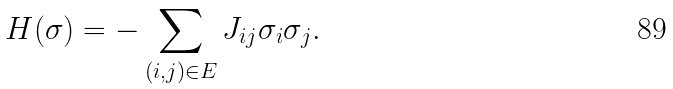Convert formula to latex. <formula><loc_0><loc_0><loc_500><loc_500>H ( \sigma ) = - \sum _ { ( i , j ) \in E } J _ { i j } \sigma _ { i } \sigma _ { j } .</formula> 